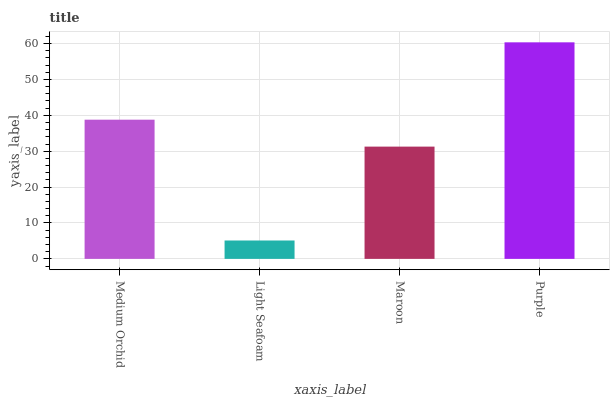Is Light Seafoam the minimum?
Answer yes or no. Yes. Is Purple the maximum?
Answer yes or no. Yes. Is Maroon the minimum?
Answer yes or no. No. Is Maroon the maximum?
Answer yes or no. No. Is Maroon greater than Light Seafoam?
Answer yes or no. Yes. Is Light Seafoam less than Maroon?
Answer yes or no. Yes. Is Light Seafoam greater than Maroon?
Answer yes or no. No. Is Maroon less than Light Seafoam?
Answer yes or no. No. Is Medium Orchid the high median?
Answer yes or no. Yes. Is Maroon the low median?
Answer yes or no. Yes. Is Maroon the high median?
Answer yes or no. No. Is Purple the low median?
Answer yes or no. No. 